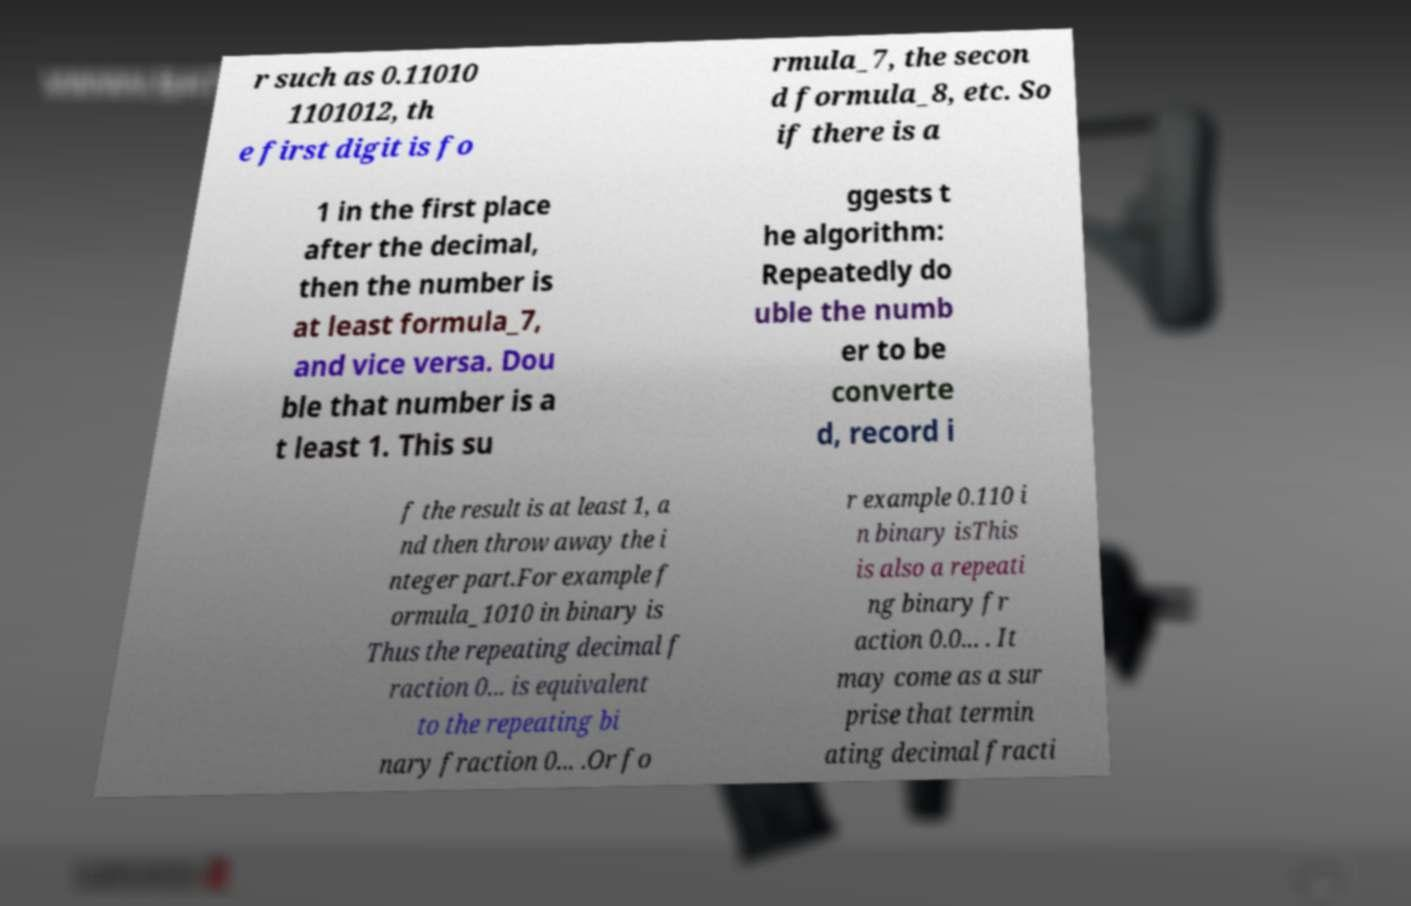Can you read and provide the text displayed in the image?This photo seems to have some interesting text. Can you extract and type it out for me? r such as 0.11010 1101012, th e first digit is fo rmula_7, the secon d formula_8, etc. So if there is a 1 in the first place after the decimal, then the number is at least formula_7, and vice versa. Dou ble that number is a t least 1. This su ggests t he algorithm: Repeatedly do uble the numb er to be converte d, record i f the result is at least 1, a nd then throw away the i nteger part.For example f ormula_1010 in binary is Thus the repeating decimal f raction 0... is equivalent to the repeating bi nary fraction 0... .Or fo r example 0.110 i n binary isThis is also a repeati ng binary fr action 0.0... . It may come as a sur prise that termin ating decimal fracti 